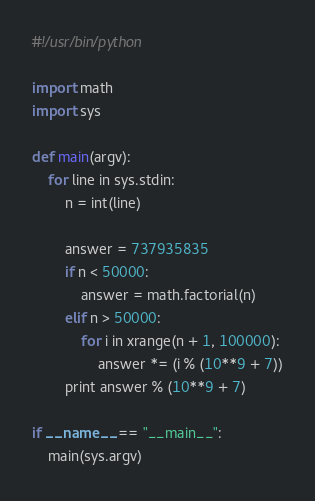Convert code to text. <code><loc_0><loc_0><loc_500><loc_500><_Python_>#!/usr/bin/python

import math
import sys

def main(argv):
    for line in sys.stdin:
        n = int(line)

        answer = 737935835
        if n < 50000:
            answer = math.factorial(n)
        elif n > 50000:
            for i in xrange(n + 1, 100000):
                answer *= (i % (10**9 + 7))
        print answer % (10**9 + 7)

if __name__ == "__main__":
    main(sys.argv)</code> 